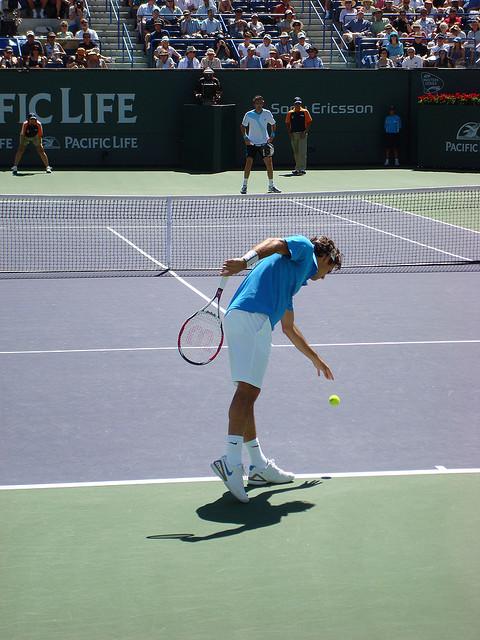What sport are they playing?
Be succinct. Tennis. Are they practicing?
Keep it brief. No. Is the tennis player about to serve or receive?
Quick response, please. Serve. What color is the court?
Give a very brief answer. Blue. 